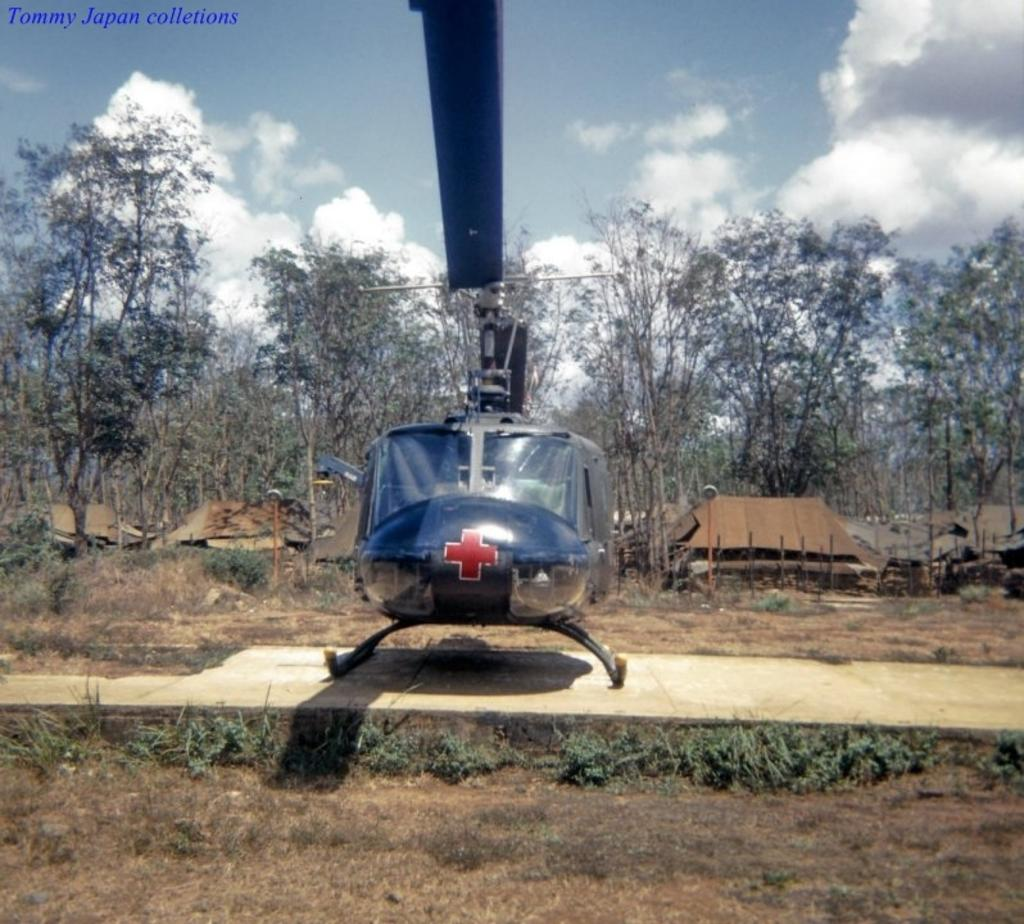What is the main subject in the center of the picture? There is a helicopter in the center of the picture. What can be seen in the foreground of the image? There are plants and grass in the foreground. What is visible in the background of the image? There are trees, houses, and plants and shrubs in the background. How would you describe the weather in the image? The sky is sunny in the image. What type of thrill can be seen in the image? There is no specific thrill depicted in the image; it features a helicopter, plants, grass, trees, houses, and plants and shrubs. What kind of bait is being used by the helicopter in the image? There is no bait or fishing activity shown in the image; it features a helicopter and various landscape elements. 